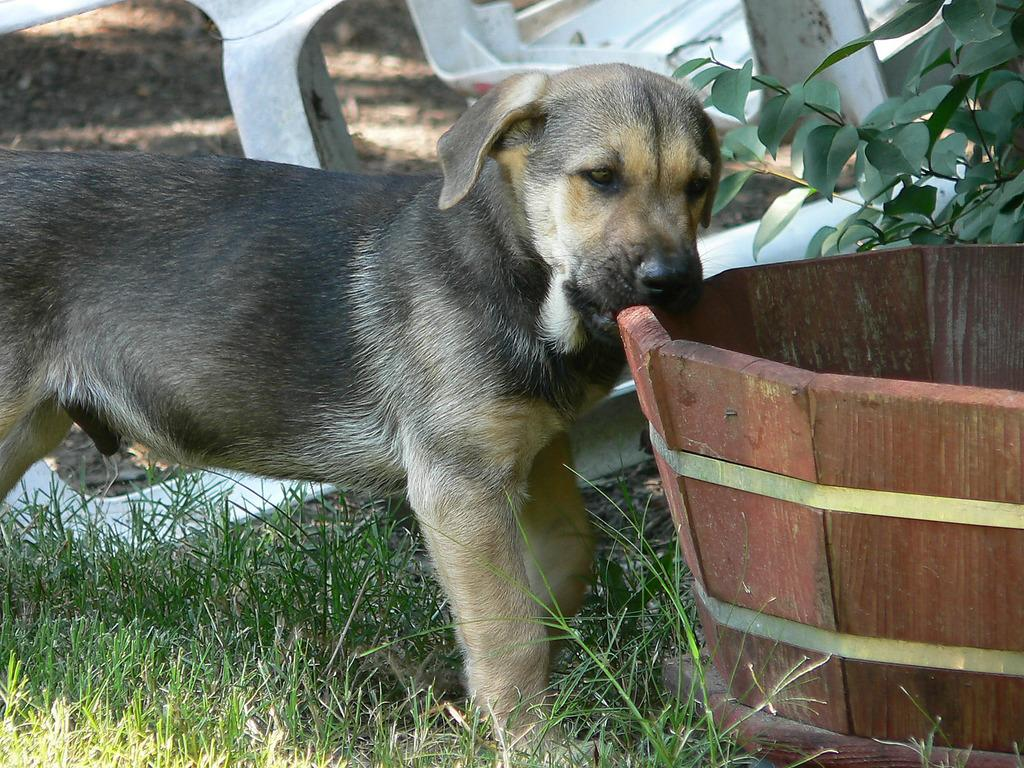What type of animal is in the image? There is a dog in the image. What is the dog doing in the image? The dog is near a house plant. What type of vegetation is visible in the image? There is grass visible in the image. What type of grain is being sold at the store in the image? There is no store or grain present in the image; it features a dog near a house plant and grass. What type of alarm is going off in the image? There is no alarm present in the image; it features a dog near a house plant and grass. 